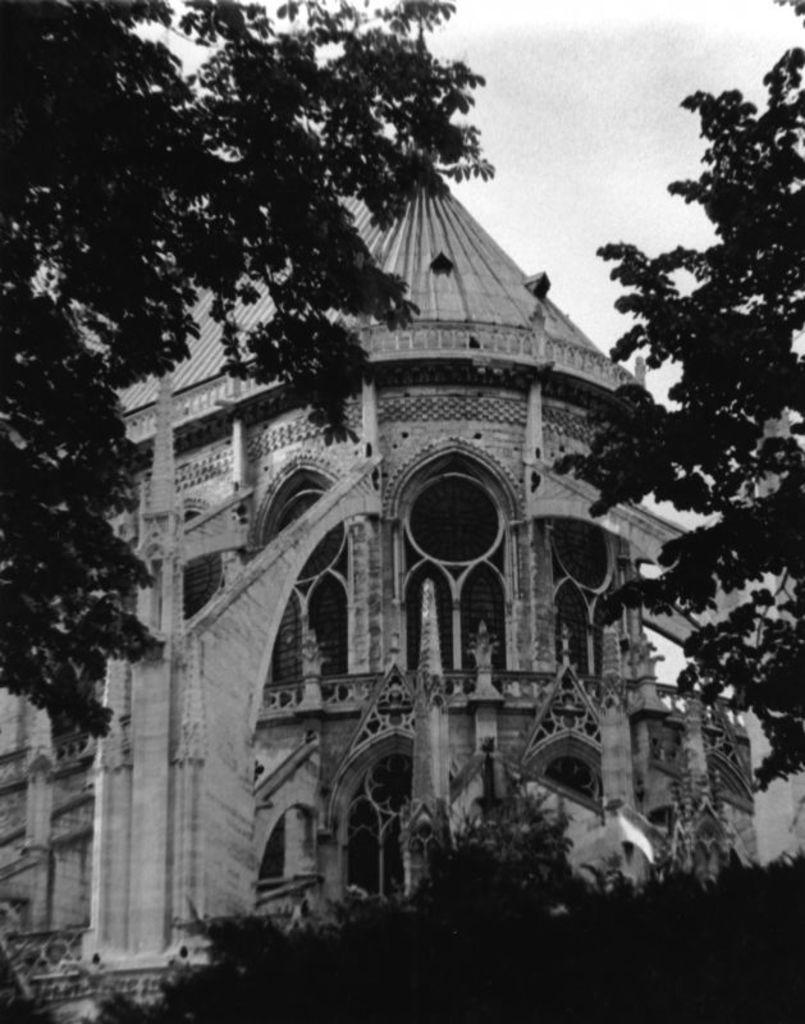Describe this image in one or two sentences. This is a black and white picture. In this picture we can see a building, trees and the sky. 